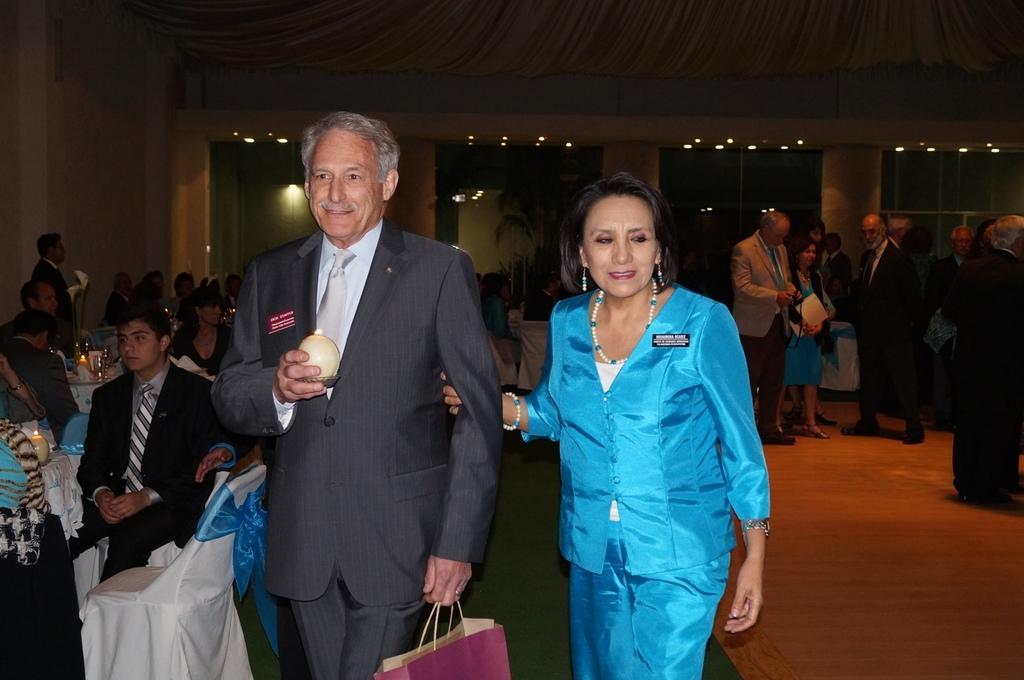In one or two sentences, can you explain what this image depicts? In the center of the image we can see two persons are standing and they are smiling, which we can see on their faces. And we can see they are holding some objects. In the background there is a wall, roof, lights, pillars, tables, chairs, few people are standing, few people are sitting, few people are holding some objects and a few other objects. On the tables, we can see candles, tissue paper, tablecloths and a few other objects. 